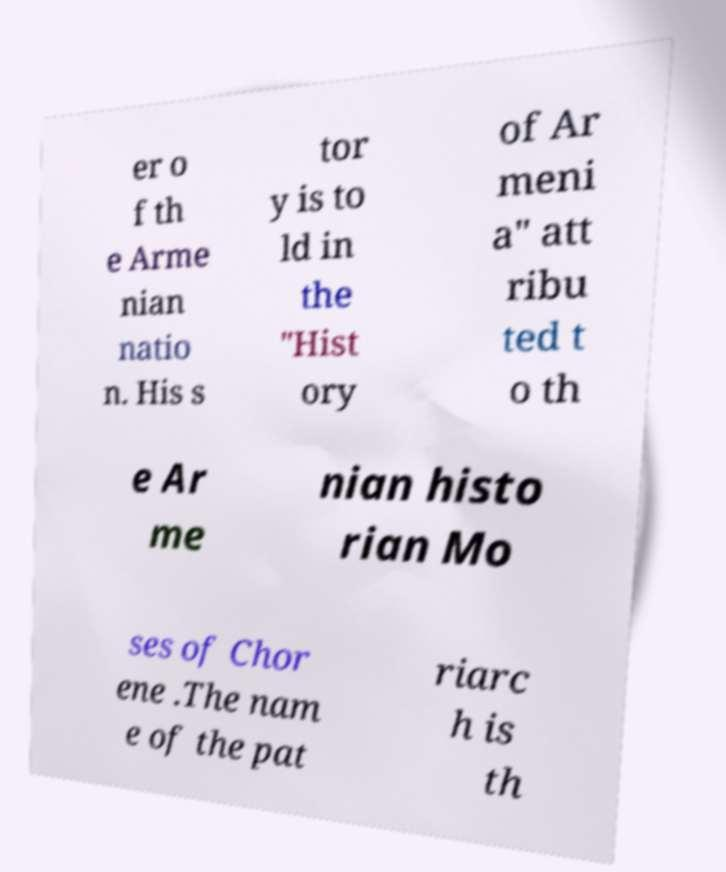There's text embedded in this image that I need extracted. Can you transcribe it verbatim? er o f th e Arme nian natio n. His s tor y is to ld in the "Hist ory of Ar meni a" att ribu ted t o th e Ar me nian histo rian Mo ses of Chor ene .The nam e of the pat riarc h is th 